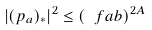Convert formula to latex. <formula><loc_0><loc_0><loc_500><loc_500>| ( p _ { a } ) _ { * } | ^ { 2 } \leq \left ( { \ f { a } { b } } \right ) ^ { 2 A }</formula> 